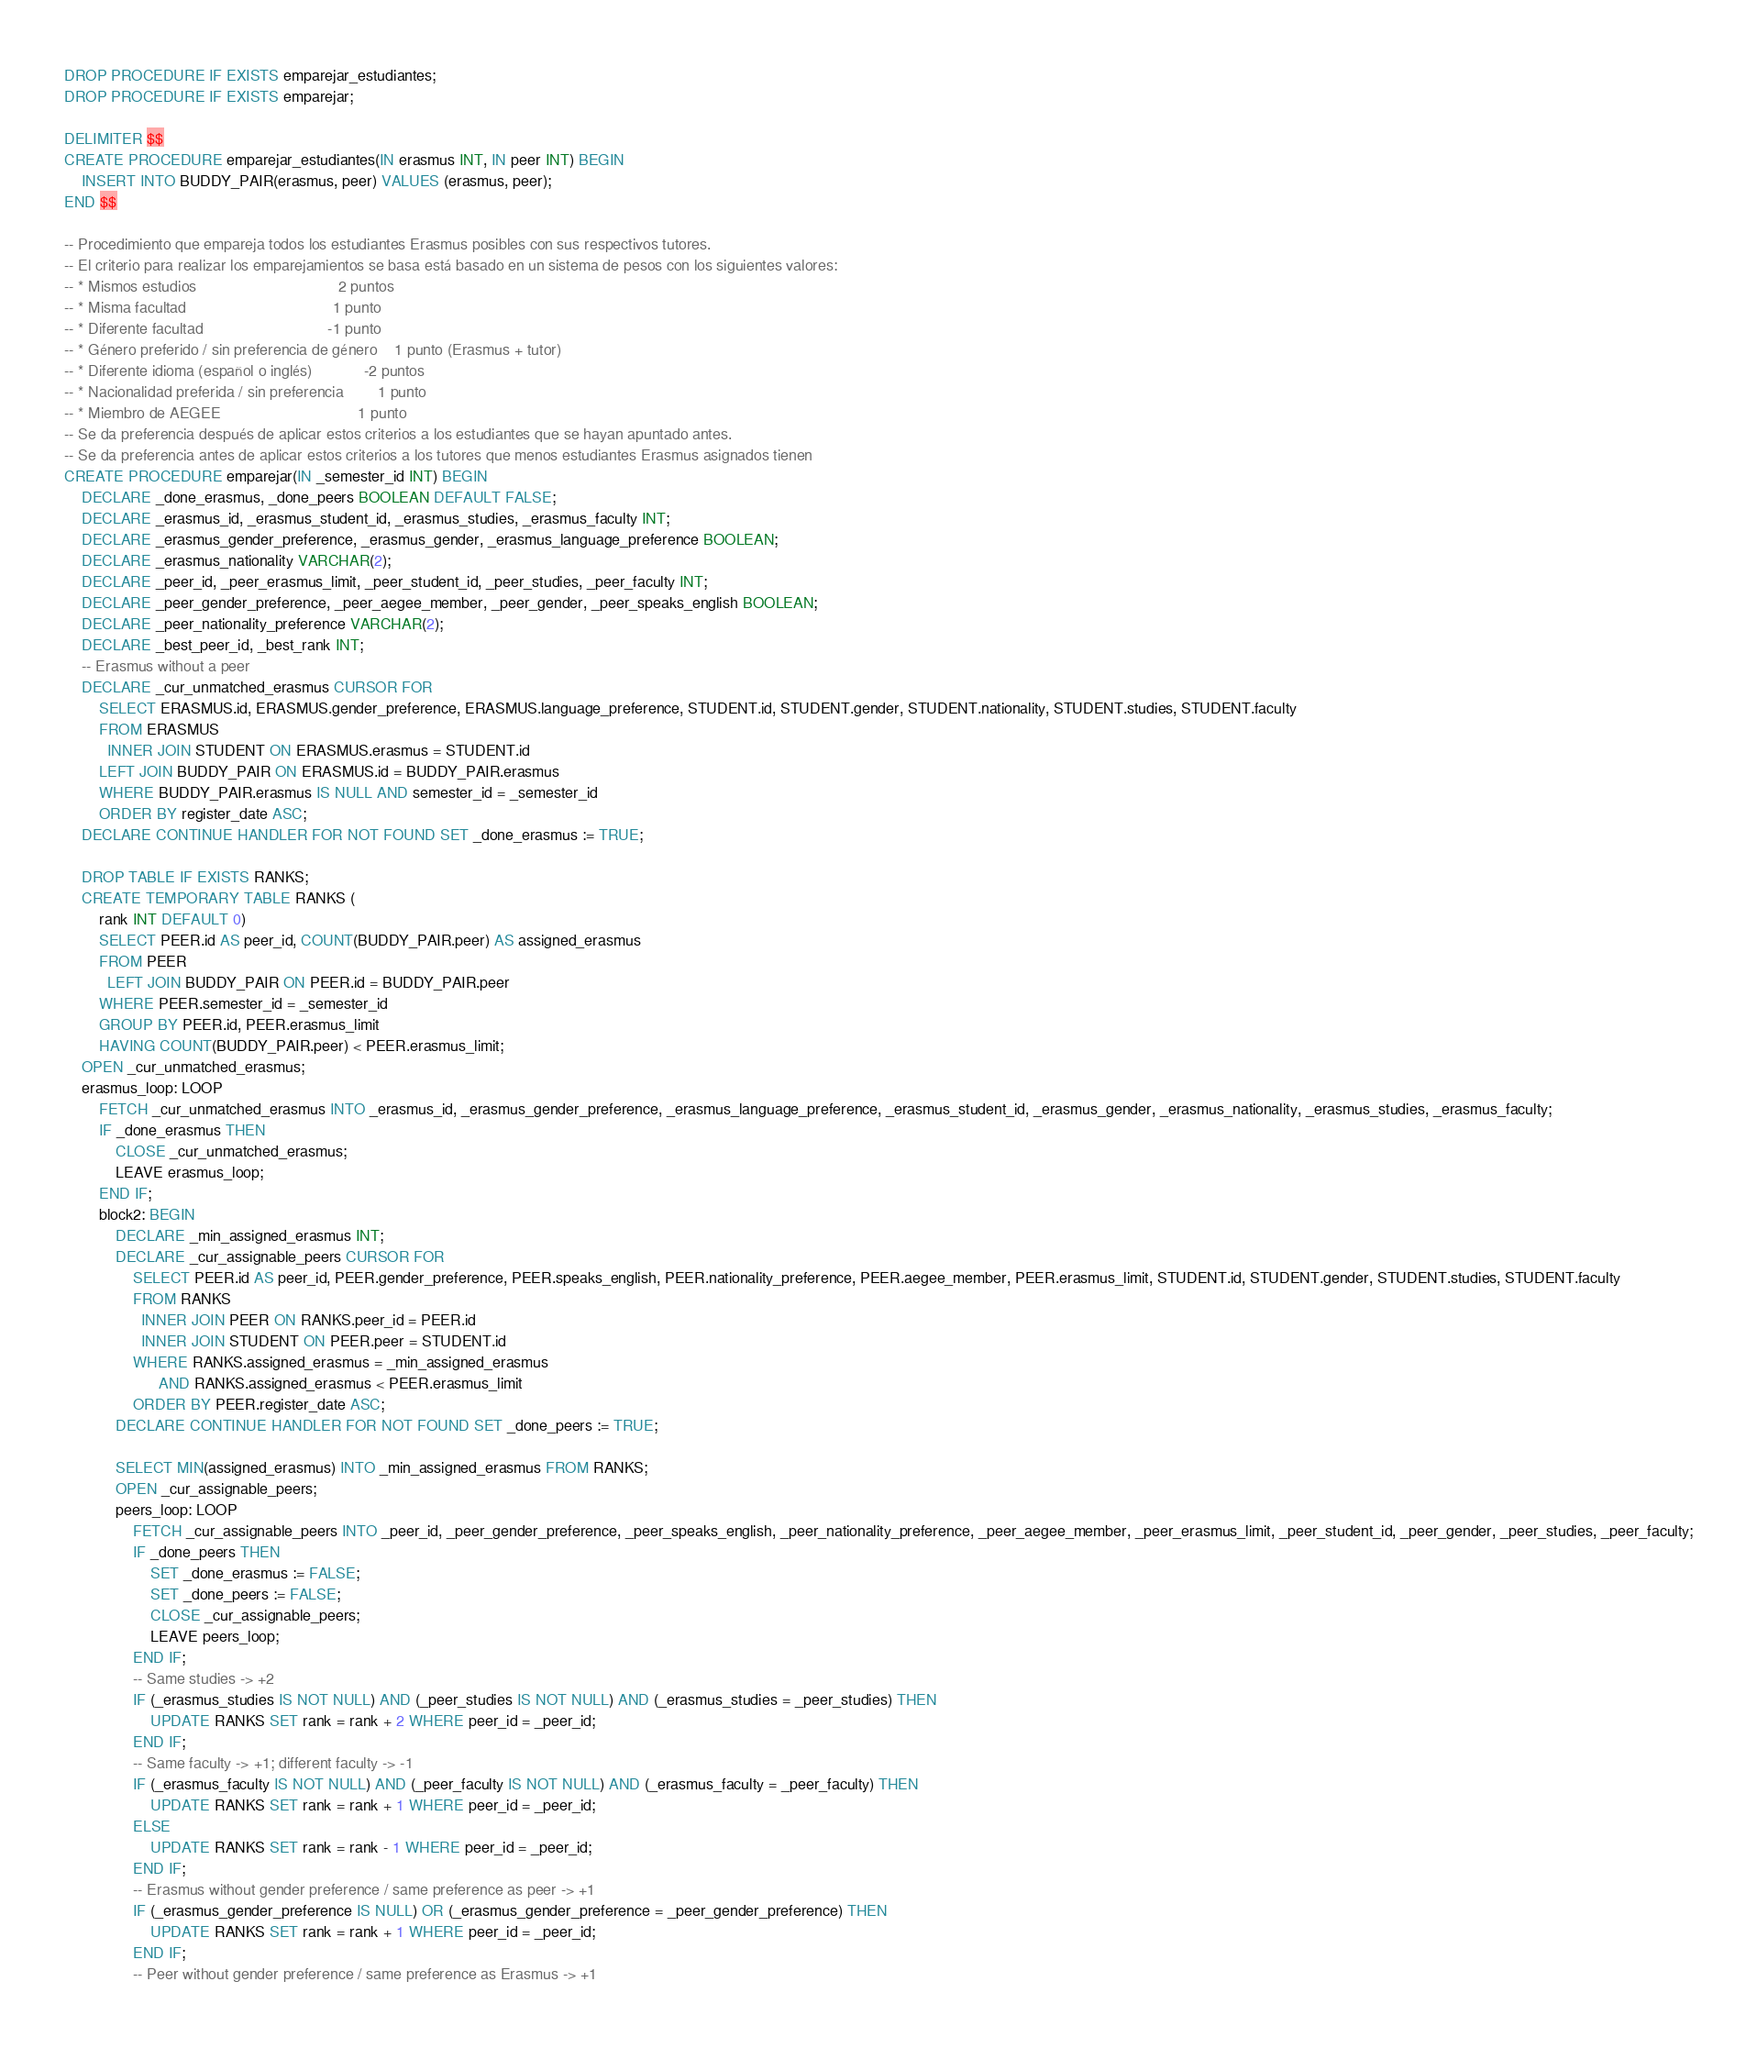Convert code to text. <code><loc_0><loc_0><loc_500><loc_500><_SQL_>DROP PROCEDURE IF EXISTS emparejar_estudiantes;
DROP PROCEDURE IF EXISTS emparejar;

DELIMITER $$
CREATE PROCEDURE emparejar_estudiantes(IN erasmus INT, IN peer INT) BEGIN
    INSERT INTO BUDDY_PAIR(erasmus, peer) VALUES (erasmus, peer);
END $$

-- Procedimiento que empareja todos los estudiantes Erasmus posibles con sus respectivos tutores.
-- El criterio para realizar los emparejamientos se basa está basado en un sistema de pesos con los siguientes valores:
-- * Mismos estudios                                 2 puntos
-- * Misma facultad                                  1 punto
-- * Diferente facultad                             -1 punto
-- * Género preferido / sin preferencia de género    1 punto (Erasmus + tutor)
-- * Diferente idioma (español o inglés)            -2 puntos
-- * Nacionalidad preferida / sin preferencia        1 punto
-- * Miembro de AEGEE                                1 punto
-- Se da preferencia después de aplicar estos criterios a los estudiantes que se hayan apuntado antes.
-- Se da preferencia antes de aplicar estos criterios a los tutores que menos estudiantes Erasmus asignados tienen
CREATE PROCEDURE emparejar(IN _semester_id INT) BEGIN
    DECLARE _done_erasmus, _done_peers BOOLEAN DEFAULT FALSE;
    DECLARE _erasmus_id, _erasmus_student_id, _erasmus_studies, _erasmus_faculty INT;
    DECLARE _erasmus_gender_preference, _erasmus_gender, _erasmus_language_preference BOOLEAN;
    DECLARE _erasmus_nationality VARCHAR(2);
    DECLARE _peer_id, _peer_erasmus_limit, _peer_student_id, _peer_studies, _peer_faculty INT;
    DECLARE _peer_gender_preference, _peer_aegee_member, _peer_gender, _peer_speaks_english BOOLEAN;
    DECLARE _peer_nationality_preference VARCHAR(2);
    DECLARE _best_peer_id, _best_rank INT;
    -- Erasmus without a peer
    DECLARE _cur_unmatched_erasmus CURSOR FOR
        SELECT ERASMUS.id, ERASMUS.gender_preference, ERASMUS.language_preference, STUDENT.id, STUDENT.gender, STUDENT.nationality, STUDENT.studies, STUDENT.faculty
        FROM ERASMUS
          INNER JOIN STUDENT ON ERASMUS.erasmus = STUDENT.id
        LEFT JOIN BUDDY_PAIR ON ERASMUS.id = BUDDY_PAIR.erasmus
        WHERE BUDDY_PAIR.erasmus IS NULL AND semester_id = _semester_id
        ORDER BY register_date ASC;
    DECLARE CONTINUE HANDLER FOR NOT FOUND SET _done_erasmus := TRUE;

    DROP TABLE IF EXISTS RANKS;
    CREATE TEMPORARY TABLE RANKS (
        rank INT DEFAULT 0)
        SELECT PEER.id AS peer_id, COUNT(BUDDY_PAIR.peer) AS assigned_erasmus
        FROM PEER
          LEFT JOIN BUDDY_PAIR ON PEER.id = BUDDY_PAIR.peer
        WHERE PEER.semester_id = _semester_id
        GROUP BY PEER.id, PEER.erasmus_limit
        HAVING COUNT(BUDDY_PAIR.peer) < PEER.erasmus_limit;
    OPEN _cur_unmatched_erasmus;
    erasmus_loop: LOOP
        FETCH _cur_unmatched_erasmus INTO _erasmus_id, _erasmus_gender_preference, _erasmus_language_preference, _erasmus_student_id, _erasmus_gender, _erasmus_nationality, _erasmus_studies, _erasmus_faculty;
        IF _done_erasmus THEN
            CLOSE _cur_unmatched_erasmus;
            LEAVE erasmus_loop;
        END IF;
        block2: BEGIN
            DECLARE _min_assigned_erasmus INT;
            DECLARE _cur_assignable_peers CURSOR FOR
                SELECT PEER.id AS peer_id, PEER.gender_preference, PEER.speaks_english, PEER.nationality_preference, PEER.aegee_member, PEER.erasmus_limit, STUDENT.id, STUDENT.gender, STUDENT.studies, STUDENT.faculty
                FROM RANKS
                  INNER JOIN PEER ON RANKS.peer_id = PEER.id
                  INNER JOIN STUDENT ON PEER.peer = STUDENT.id
                WHERE RANKS.assigned_erasmus = _min_assigned_erasmus
                      AND RANKS.assigned_erasmus < PEER.erasmus_limit
                ORDER BY PEER.register_date ASC;
            DECLARE CONTINUE HANDLER FOR NOT FOUND SET _done_peers := TRUE;

            SELECT MIN(assigned_erasmus) INTO _min_assigned_erasmus FROM RANKS;
            OPEN _cur_assignable_peers;
            peers_loop: LOOP
                FETCH _cur_assignable_peers INTO _peer_id, _peer_gender_preference, _peer_speaks_english, _peer_nationality_preference, _peer_aegee_member, _peer_erasmus_limit, _peer_student_id, _peer_gender, _peer_studies, _peer_faculty;
                IF _done_peers THEN
                    SET _done_erasmus := FALSE;
                    SET _done_peers := FALSE;
                    CLOSE _cur_assignable_peers;
                    LEAVE peers_loop;
                END IF;
                -- Same studies -> +2
                IF (_erasmus_studies IS NOT NULL) AND (_peer_studies IS NOT NULL) AND (_erasmus_studies = _peer_studies) THEN
                    UPDATE RANKS SET rank = rank + 2 WHERE peer_id = _peer_id;
                END IF;
                -- Same faculty -> +1; different faculty -> -1
                IF (_erasmus_faculty IS NOT NULL) AND (_peer_faculty IS NOT NULL) AND (_erasmus_faculty = _peer_faculty) THEN
                    UPDATE RANKS SET rank = rank + 1 WHERE peer_id = _peer_id;
                ELSE
                    UPDATE RANKS SET rank = rank - 1 WHERE peer_id = _peer_id;
                END IF;
                -- Erasmus without gender preference / same preference as peer -> +1
                IF (_erasmus_gender_preference IS NULL) OR (_erasmus_gender_preference = _peer_gender_preference) THEN
                    UPDATE RANKS SET rank = rank + 1 WHERE peer_id = _peer_id;
                END IF;
                -- Peer without gender preference / same preference as Erasmus -> +1</code> 